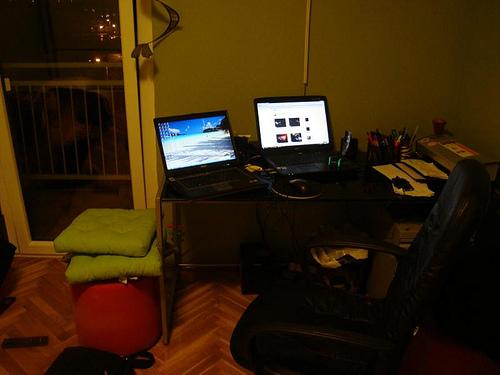Is the laptop plugged in?
Short answer required. Yes. What is on the cart?
Write a very short answer. Computers. What type of door is in the room?
Be succinct. Screen. Are the pets or children in this house?
Keep it brief. Yes. What number of open laptops are there?
Quick response, please. 2. 